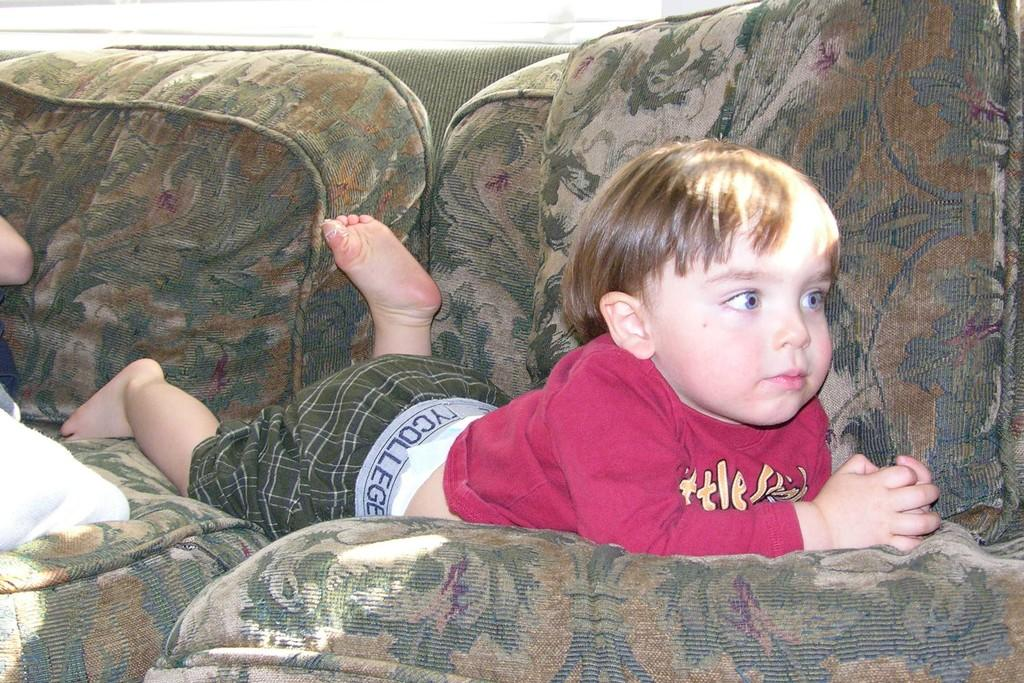Who is the main subject in the image? There is a small boy in the image. What is the boy wearing? The boy is wearing a pink t-shirt. Where is the boy located in the image? The boy is lying on a green sofa. What type of dinosaurs can be seen in the image? There are no dinosaurs present in the image; it features a small boy lying on a green sofa while wearing a pink t-shirt. 